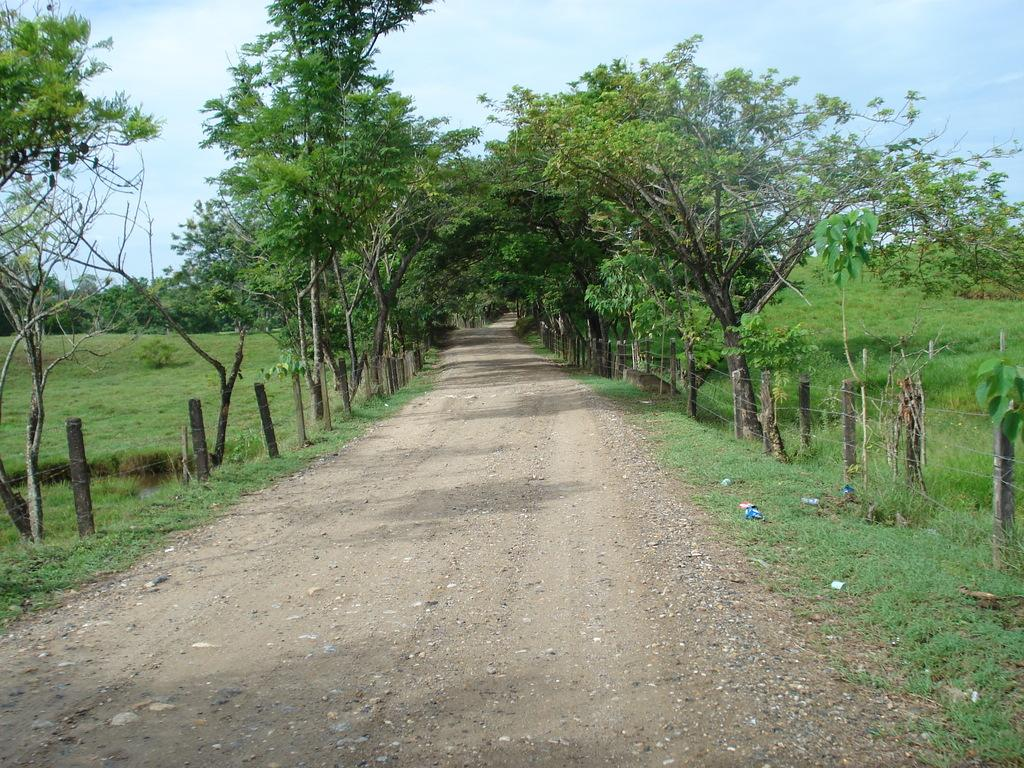What type of surface can be seen in the image? There is a road in the image. What is the purpose of the fencing visible in the image? The purpose of the fencing is not specified, but it is visible in the image. What type of vegetation can be seen in the image? There are trees and grass in the image. How many flowers are on the donkey in the image? There is no donkey or flowers present in the image. 